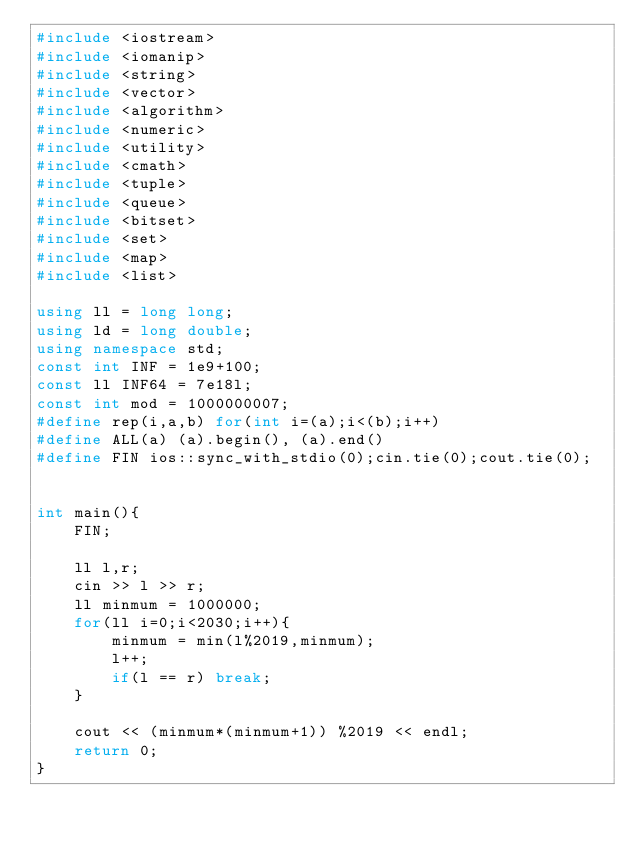<code> <loc_0><loc_0><loc_500><loc_500><_C++_>#include <iostream>
#include <iomanip>
#include <string>
#include <vector>
#include <algorithm>
#include <numeric>
#include <utility>
#include <cmath>
#include <tuple>
#include <queue>
#include <bitset>
#include <set>
#include <map>
#include <list>

using ll = long long;
using ld = long double;
using namespace std;
const int INF = 1e9+100;
const ll INF64 = 7e18l;
const int mod = 1000000007;
#define rep(i,a,b) for(int i=(a);i<(b);i++)
#define ALL(a) (a).begin(), (a).end()
#define FIN ios::sync_with_stdio(0);cin.tie(0);cout.tie(0);


int main(){
    FIN;

    ll l,r;
    cin >> l >> r;
    ll minmum = 1000000;
    for(ll i=0;i<2030;i++){
        minmum = min(l%2019,minmum);
        l++;
        if(l == r) break;
    }

    cout << (minmum*(minmum+1)) %2019 << endl;
    return 0;
}
</code> 